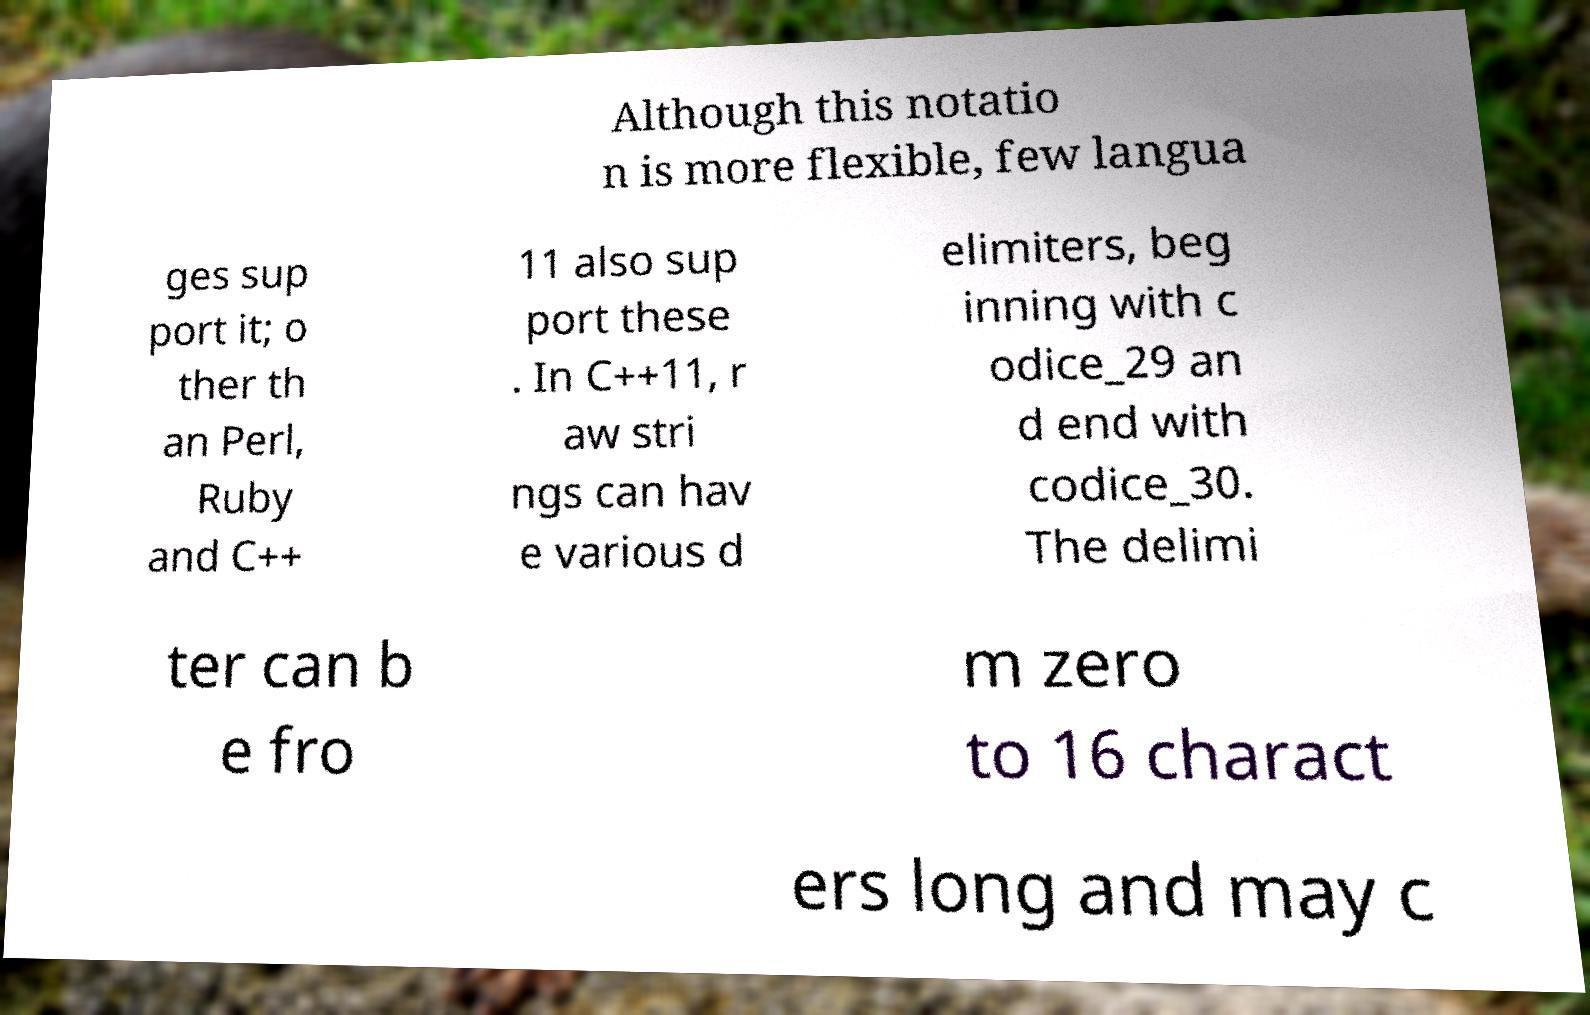Please read and relay the text visible in this image. What does it say? Although this notatio n is more flexible, few langua ges sup port it; o ther th an Perl, Ruby and C++ 11 also sup port these . In C++11, r aw stri ngs can hav e various d elimiters, beg inning with c odice_29 an d end with codice_30. The delimi ter can b e fro m zero to 16 charact ers long and may c 